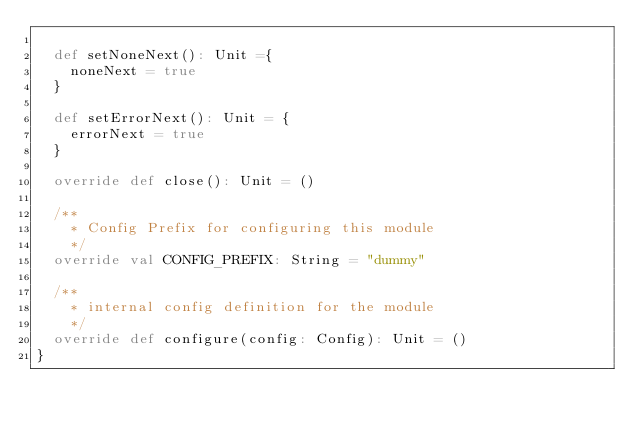Convert code to text. <code><loc_0><loc_0><loc_500><loc_500><_Scala_>
  def setNoneNext(): Unit ={
    noneNext = true
  }

  def setErrorNext(): Unit = {
    errorNext = true
  }

  override def close(): Unit = ()

  /**
    * Config Prefix for configuring this module
    */
  override val CONFIG_PREFIX: String = "dummy"

  /**
    * internal config definition for the module
    */
  override def configure(config: Config): Unit = ()
}
</code> 